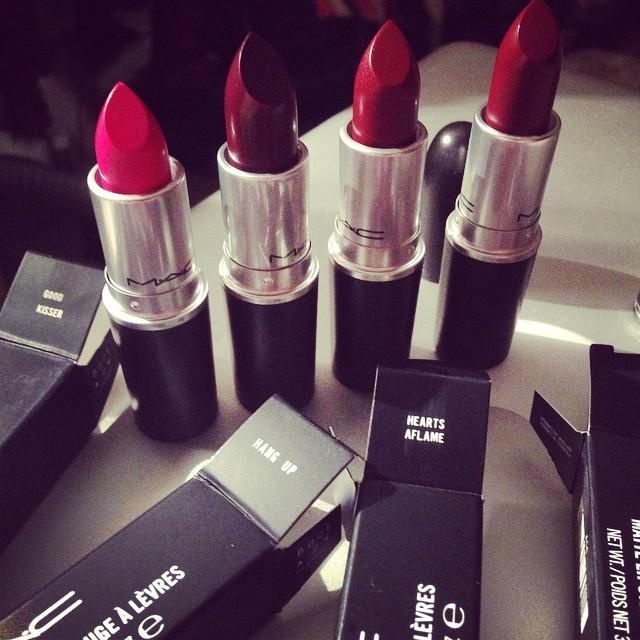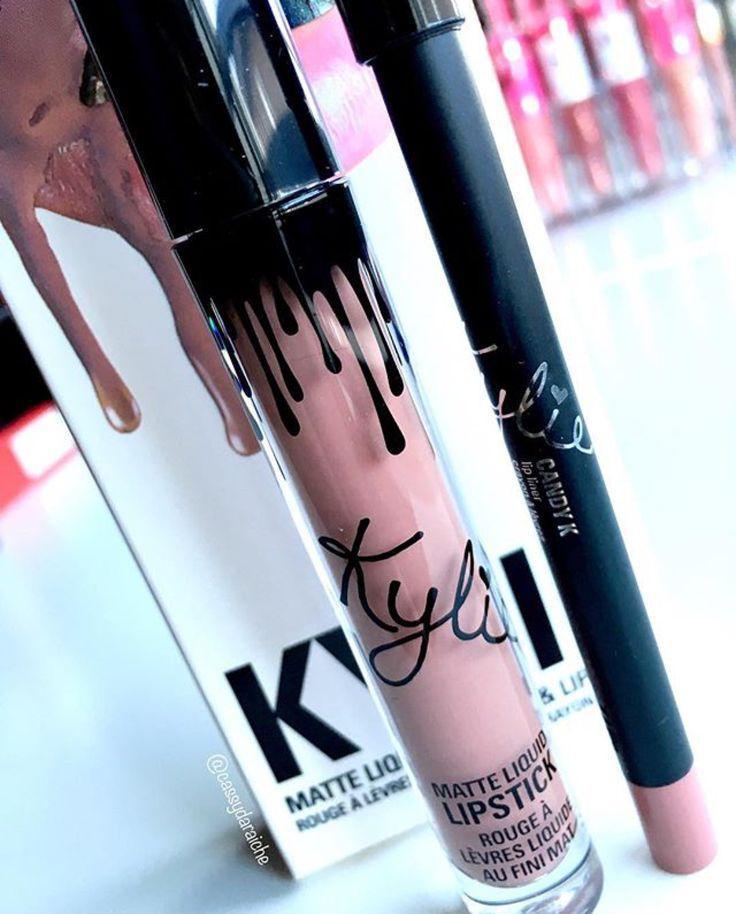The first image is the image on the left, the second image is the image on the right. Analyze the images presented: Is the assertion "A human hand is holding a lipstick without a cap." valid? Answer yes or no. No. The first image is the image on the left, the second image is the image on the right. Analyze the images presented: Is the assertion "An image shows a hand holding an opened lipstick." valid? Answer yes or no. No. 